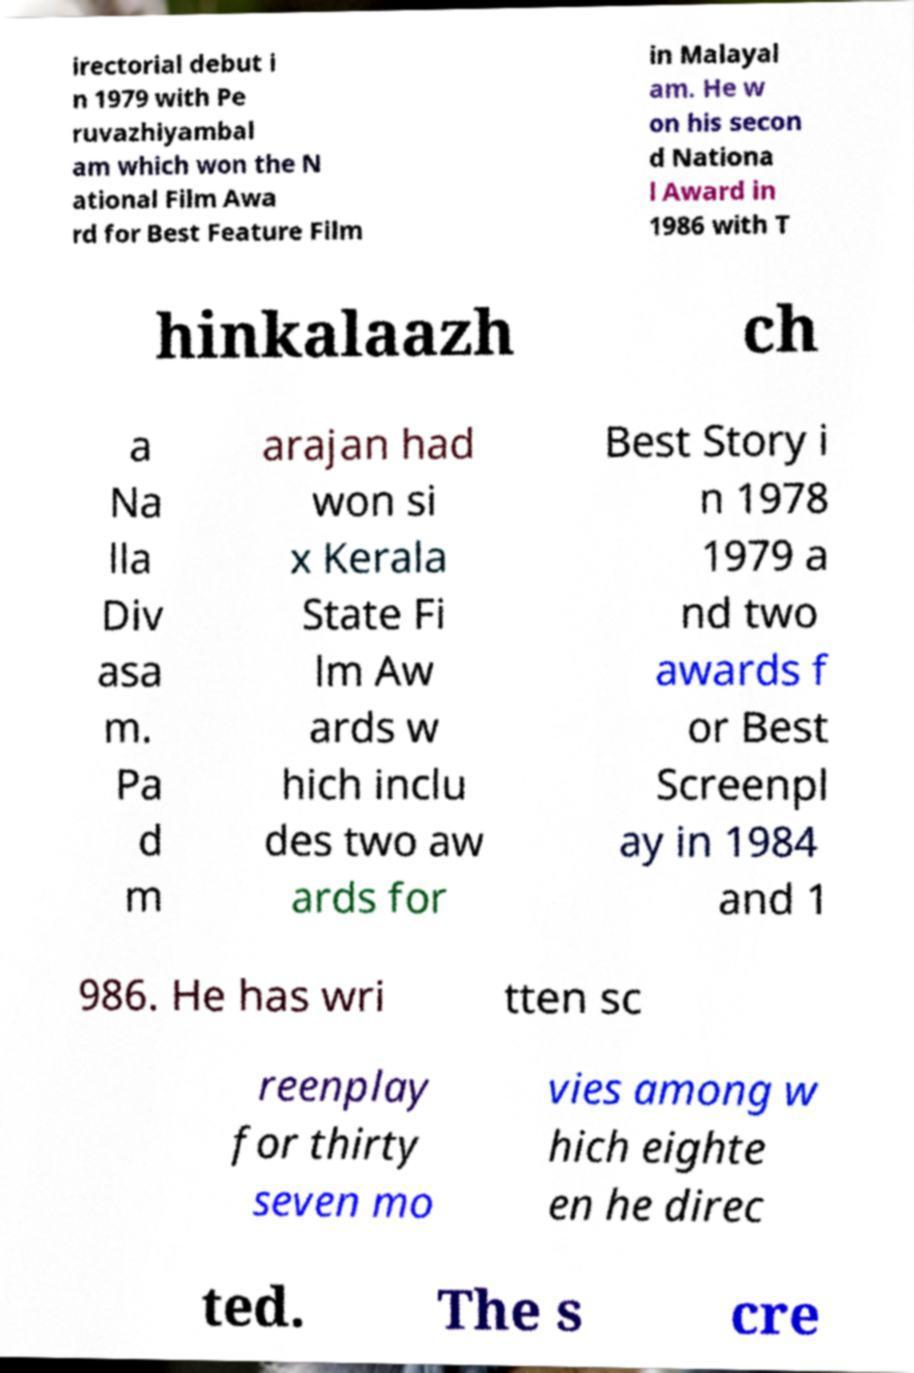Please identify and transcribe the text found in this image. irectorial debut i n 1979 with Pe ruvazhiyambal am which won the N ational Film Awa rd for Best Feature Film in Malayal am. He w on his secon d Nationa l Award in 1986 with T hinkalaazh ch a Na lla Div asa m. Pa d m arajan had won si x Kerala State Fi lm Aw ards w hich inclu des two aw ards for Best Story i n 1978 1979 a nd two awards f or Best Screenpl ay in 1984 and 1 986. He has wri tten sc reenplay for thirty seven mo vies among w hich eighte en he direc ted. The s cre 